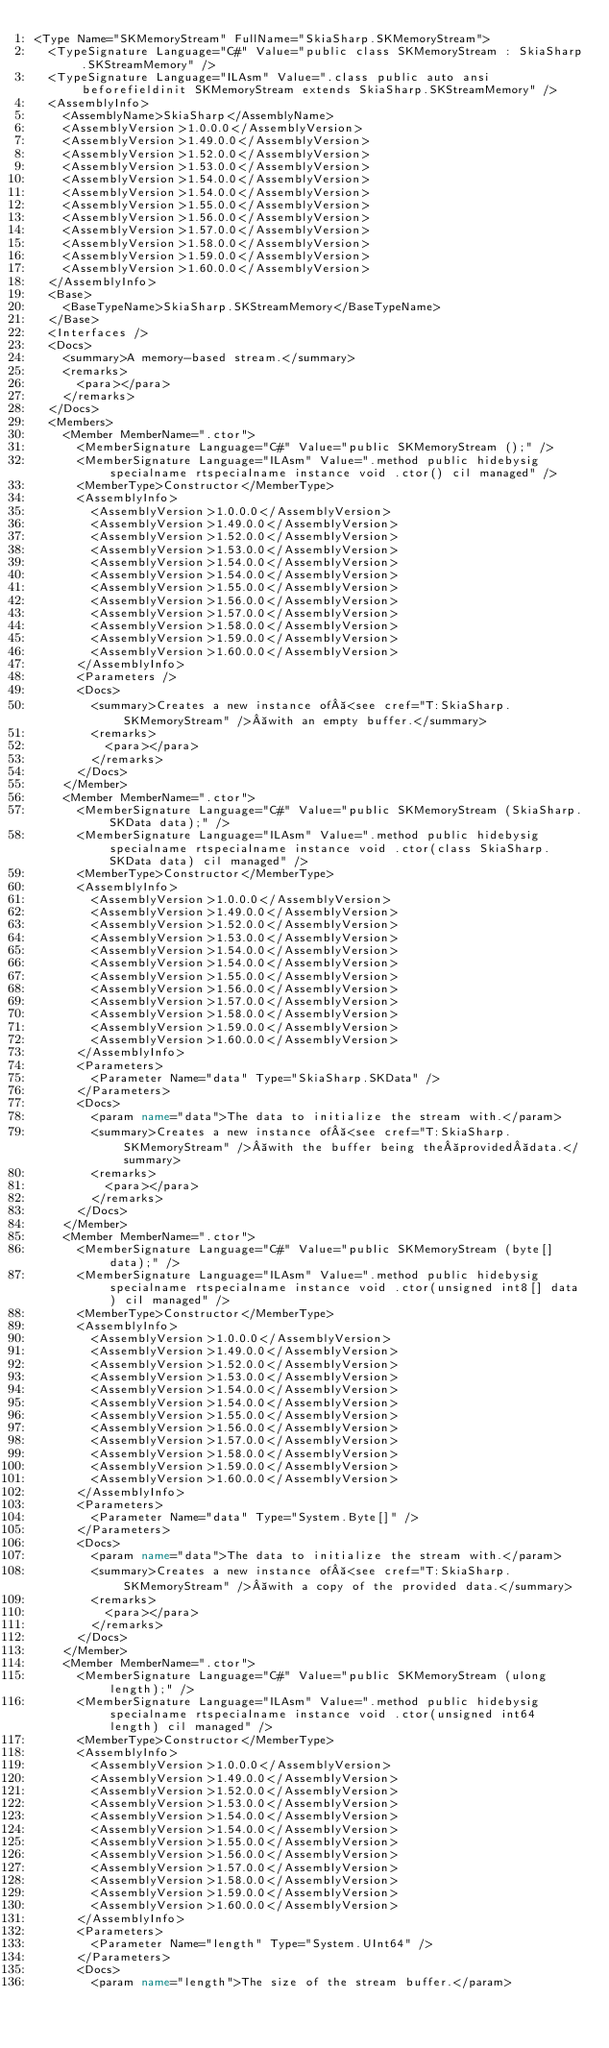Convert code to text. <code><loc_0><loc_0><loc_500><loc_500><_XML_><Type Name="SKMemoryStream" FullName="SkiaSharp.SKMemoryStream">
  <TypeSignature Language="C#" Value="public class SKMemoryStream : SkiaSharp.SKStreamMemory" />
  <TypeSignature Language="ILAsm" Value=".class public auto ansi beforefieldinit SKMemoryStream extends SkiaSharp.SKStreamMemory" />
  <AssemblyInfo>
    <AssemblyName>SkiaSharp</AssemblyName>
    <AssemblyVersion>1.0.0.0</AssemblyVersion>
    <AssemblyVersion>1.49.0.0</AssemblyVersion>
    <AssemblyVersion>1.52.0.0</AssemblyVersion>
    <AssemblyVersion>1.53.0.0</AssemblyVersion>
    <AssemblyVersion>1.54.0.0</AssemblyVersion>
    <AssemblyVersion>1.54.0.0</AssemblyVersion>
    <AssemblyVersion>1.55.0.0</AssemblyVersion>
    <AssemblyVersion>1.56.0.0</AssemblyVersion>
    <AssemblyVersion>1.57.0.0</AssemblyVersion>
    <AssemblyVersion>1.58.0.0</AssemblyVersion>
    <AssemblyVersion>1.59.0.0</AssemblyVersion>
    <AssemblyVersion>1.60.0.0</AssemblyVersion>
  </AssemblyInfo>
  <Base>
    <BaseTypeName>SkiaSharp.SKStreamMemory</BaseTypeName>
  </Base>
  <Interfaces />
  <Docs>
    <summary>A memory-based stream.</summary>
    <remarks>
      <para></para>
    </remarks>
  </Docs>
  <Members>
    <Member MemberName=".ctor">
      <MemberSignature Language="C#" Value="public SKMemoryStream ();" />
      <MemberSignature Language="ILAsm" Value=".method public hidebysig specialname rtspecialname instance void .ctor() cil managed" />
      <MemberType>Constructor</MemberType>
      <AssemblyInfo>
        <AssemblyVersion>1.0.0.0</AssemblyVersion>
        <AssemblyVersion>1.49.0.0</AssemblyVersion>
        <AssemblyVersion>1.52.0.0</AssemblyVersion>
        <AssemblyVersion>1.53.0.0</AssemblyVersion>
        <AssemblyVersion>1.54.0.0</AssemblyVersion>
        <AssemblyVersion>1.54.0.0</AssemblyVersion>
        <AssemblyVersion>1.55.0.0</AssemblyVersion>
        <AssemblyVersion>1.56.0.0</AssemblyVersion>
        <AssemblyVersion>1.57.0.0</AssemblyVersion>
        <AssemblyVersion>1.58.0.0</AssemblyVersion>
        <AssemblyVersion>1.59.0.0</AssemblyVersion>
        <AssemblyVersion>1.60.0.0</AssemblyVersion>
      </AssemblyInfo>
      <Parameters />
      <Docs>
        <summary>Creates a new instance of <see cref="T:SkiaSharp.SKMemoryStream" /> with an empty buffer.</summary>
        <remarks>
          <para></para>
        </remarks>
      </Docs>
    </Member>
    <Member MemberName=".ctor">
      <MemberSignature Language="C#" Value="public SKMemoryStream (SkiaSharp.SKData data);" />
      <MemberSignature Language="ILAsm" Value=".method public hidebysig specialname rtspecialname instance void .ctor(class SkiaSharp.SKData data) cil managed" />
      <MemberType>Constructor</MemberType>
      <AssemblyInfo>
        <AssemblyVersion>1.0.0.0</AssemblyVersion>
        <AssemblyVersion>1.49.0.0</AssemblyVersion>
        <AssemblyVersion>1.52.0.0</AssemblyVersion>
        <AssemblyVersion>1.53.0.0</AssemblyVersion>
        <AssemblyVersion>1.54.0.0</AssemblyVersion>
        <AssemblyVersion>1.54.0.0</AssemblyVersion>
        <AssemblyVersion>1.55.0.0</AssemblyVersion>
        <AssemblyVersion>1.56.0.0</AssemblyVersion>
        <AssemblyVersion>1.57.0.0</AssemblyVersion>
        <AssemblyVersion>1.58.0.0</AssemblyVersion>
        <AssemblyVersion>1.59.0.0</AssemblyVersion>
        <AssemblyVersion>1.60.0.0</AssemblyVersion>
      </AssemblyInfo>
      <Parameters>
        <Parameter Name="data" Type="SkiaSharp.SKData" />
      </Parameters>
      <Docs>
        <param name="data">The data to initialize the stream with.</param>
        <summary>Creates a new instance of <see cref="T:SkiaSharp.SKMemoryStream" /> with the buffer being the provided data.</summary>
        <remarks>
          <para></para>
        </remarks>
      </Docs>
    </Member>
    <Member MemberName=".ctor">
      <MemberSignature Language="C#" Value="public SKMemoryStream (byte[] data);" />
      <MemberSignature Language="ILAsm" Value=".method public hidebysig specialname rtspecialname instance void .ctor(unsigned int8[] data) cil managed" />
      <MemberType>Constructor</MemberType>
      <AssemblyInfo>
        <AssemblyVersion>1.0.0.0</AssemblyVersion>
        <AssemblyVersion>1.49.0.0</AssemblyVersion>
        <AssemblyVersion>1.52.0.0</AssemblyVersion>
        <AssemblyVersion>1.53.0.0</AssemblyVersion>
        <AssemblyVersion>1.54.0.0</AssemblyVersion>
        <AssemblyVersion>1.54.0.0</AssemblyVersion>
        <AssemblyVersion>1.55.0.0</AssemblyVersion>
        <AssemblyVersion>1.56.0.0</AssemblyVersion>
        <AssemblyVersion>1.57.0.0</AssemblyVersion>
        <AssemblyVersion>1.58.0.0</AssemblyVersion>
        <AssemblyVersion>1.59.0.0</AssemblyVersion>
        <AssemblyVersion>1.60.0.0</AssemblyVersion>
      </AssemblyInfo>
      <Parameters>
        <Parameter Name="data" Type="System.Byte[]" />
      </Parameters>
      <Docs>
        <param name="data">The data to initialize the stream with.</param>
        <summary>Creates a new instance of <see cref="T:SkiaSharp.SKMemoryStream" /> with a copy of the provided data.</summary>
        <remarks>
          <para></para>
        </remarks>
      </Docs>
    </Member>
    <Member MemberName=".ctor">
      <MemberSignature Language="C#" Value="public SKMemoryStream (ulong length);" />
      <MemberSignature Language="ILAsm" Value=".method public hidebysig specialname rtspecialname instance void .ctor(unsigned int64 length) cil managed" />
      <MemberType>Constructor</MemberType>
      <AssemblyInfo>
        <AssemblyVersion>1.0.0.0</AssemblyVersion>
        <AssemblyVersion>1.49.0.0</AssemblyVersion>
        <AssemblyVersion>1.52.0.0</AssemblyVersion>
        <AssemblyVersion>1.53.0.0</AssemblyVersion>
        <AssemblyVersion>1.54.0.0</AssemblyVersion>
        <AssemblyVersion>1.54.0.0</AssemblyVersion>
        <AssemblyVersion>1.55.0.0</AssemblyVersion>
        <AssemblyVersion>1.56.0.0</AssemblyVersion>
        <AssemblyVersion>1.57.0.0</AssemblyVersion>
        <AssemblyVersion>1.58.0.0</AssemblyVersion>
        <AssemblyVersion>1.59.0.0</AssemblyVersion>
        <AssemblyVersion>1.60.0.0</AssemblyVersion>
      </AssemblyInfo>
      <Parameters>
        <Parameter Name="length" Type="System.UInt64" />
      </Parameters>
      <Docs>
        <param name="length">The size of the stream buffer.</param></code> 